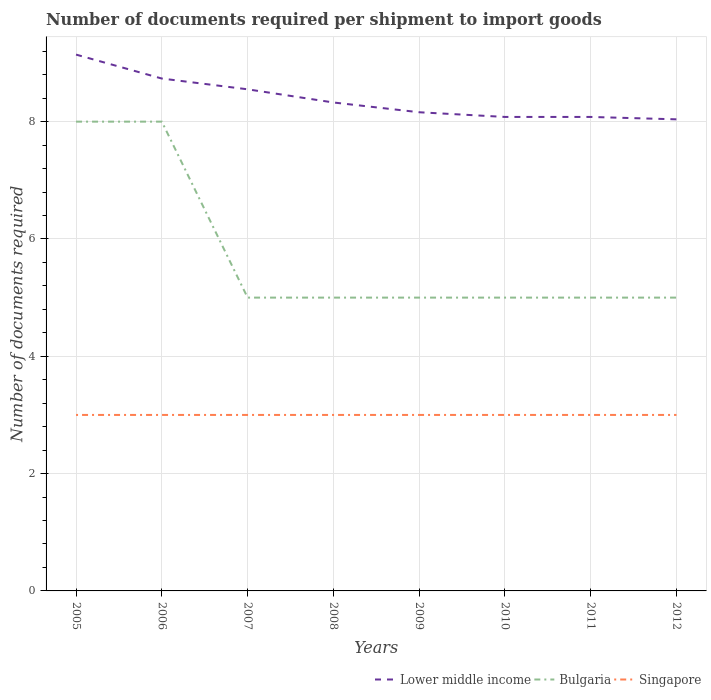Does the line corresponding to Bulgaria intersect with the line corresponding to Singapore?
Your answer should be compact. No. Is the number of lines equal to the number of legend labels?
Offer a terse response. Yes. Across all years, what is the maximum number of documents required per shipment to import goods in Singapore?
Keep it short and to the point. 3. What is the total number of documents required per shipment to import goods in Lower middle income in the graph?
Provide a succinct answer. 0.41. What is the difference between the highest and the lowest number of documents required per shipment to import goods in Lower middle income?
Provide a succinct answer. 3. How many lines are there?
Keep it short and to the point. 3. Where does the legend appear in the graph?
Provide a short and direct response. Bottom right. How many legend labels are there?
Give a very brief answer. 3. What is the title of the graph?
Provide a succinct answer. Number of documents required per shipment to import goods. What is the label or title of the Y-axis?
Make the answer very short. Number of documents required. What is the Number of documents required in Lower middle income in 2005?
Your response must be concise. 9.14. What is the Number of documents required in Lower middle income in 2006?
Your answer should be compact. 8.73. What is the Number of documents required of Bulgaria in 2006?
Provide a succinct answer. 8. What is the Number of documents required of Lower middle income in 2007?
Give a very brief answer. 8.55. What is the Number of documents required of Lower middle income in 2008?
Ensure brevity in your answer.  8.33. What is the Number of documents required in Bulgaria in 2008?
Your answer should be very brief. 5. What is the Number of documents required in Singapore in 2008?
Your answer should be compact. 3. What is the Number of documents required of Lower middle income in 2009?
Make the answer very short. 8.16. What is the Number of documents required of Lower middle income in 2010?
Ensure brevity in your answer.  8.08. What is the Number of documents required of Lower middle income in 2011?
Your answer should be compact. 8.08. What is the Number of documents required in Bulgaria in 2011?
Offer a terse response. 5. What is the Number of documents required in Singapore in 2011?
Give a very brief answer. 3. What is the Number of documents required in Lower middle income in 2012?
Your response must be concise. 8.04. What is the Number of documents required in Bulgaria in 2012?
Ensure brevity in your answer.  5. What is the Number of documents required in Singapore in 2012?
Keep it short and to the point. 3. Across all years, what is the maximum Number of documents required in Lower middle income?
Ensure brevity in your answer.  9.14. Across all years, what is the maximum Number of documents required of Bulgaria?
Provide a short and direct response. 8. Across all years, what is the minimum Number of documents required of Lower middle income?
Offer a terse response. 8.04. Across all years, what is the minimum Number of documents required of Bulgaria?
Provide a succinct answer. 5. What is the total Number of documents required of Lower middle income in the graph?
Offer a very short reply. 67.11. What is the total Number of documents required in Bulgaria in the graph?
Your answer should be very brief. 46. What is the total Number of documents required in Singapore in the graph?
Provide a succinct answer. 24. What is the difference between the Number of documents required in Lower middle income in 2005 and that in 2006?
Provide a short and direct response. 0.41. What is the difference between the Number of documents required of Lower middle income in 2005 and that in 2007?
Offer a very short reply. 0.59. What is the difference between the Number of documents required of Bulgaria in 2005 and that in 2007?
Offer a very short reply. 3. What is the difference between the Number of documents required in Singapore in 2005 and that in 2007?
Ensure brevity in your answer.  0. What is the difference between the Number of documents required in Lower middle income in 2005 and that in 2008?
Your answer should be compact. 0.82. What is the difference between the Number of documents required of Bulgaria in 2005 and that in 2008?
Your answer should be very brief. 3. What is the difference between the Number of documents required of Singapore in 2005 and that in 2008?
Offer a very short reply. 0. What is the difference between the Number of documents required of Lower middle income in 2005 and that in 2009?
Make the answer very short. 0.98. What is the difference between the Number of documents required in Lower middle income in 2005 and that in 2010?
Offer a terse response. 1.06. What is the difference between the Number of documents required of Bulgaria in 2005 and that in 2010?
Give a very brief answer. 3. What is the difference between the Number of documents required of Lower middle income in 2005 and that in 2011?
Your response must be concise. 1.06. What is the difference between the Number of documents required in Bulgaria in 2005 and that in 2011?
Provide a short and direct response. 3. What is the difference between the Number of documents required of Lower middle income in 2005 and that in 2012?
Your answer should be compact. 1.1. What is the difference between the Number of documents required in Bulgaria in 2005 and that in 2012?
Provide a succinct answer. 3. What is the difference between the Number of documents required of Lower middle income in 2006 and that in 2007?
Keep it short and to the point. 0.18. What is the difference between the Number of documents required in Singapore in 2006 and that in 2007?
Keep it short and to the point. 0. What is the difference between the Number of documents required in Lower middle income in 2006 and that in 2008?
Make the answer very short. 0.41. What is the difference between the Number of documents required of Lower middle income in 2006 and that in 2009?
Provide a short and direct response. 0.57. What is the difference between the Number of documents required of Bulgaria in 2006 and that in 2009?
Offer a very short reply. 3. What is the difference between the Number of documents required in Lower middle income in 2006 and that in 2010?
Ensure brevity in your answer.  0.65. What is the difference between the Number of documents required in Singapore in 2006 and that in 2010?
Provide a succinct answer. 0. What is the difference between the Number of documents required of Lower middle income in 2006 and that in 2011?
Provide a succinct answer. 0.65. What is the difference between the Number of documents required in Bulgaria in 2006 and that in 2011?
Keep it short and to the point. 3. What is the difference between the Number of documents required of Singapore in 2006 and that in 2011?
Ensure brevity in your answer.  0. What is the difference between the Number of documents required of Lower middle income in 2006 and that in 2012?
Give a very brief answer. 0.7. What is the difference between the Number of documents required in Singapore in 2006 and that in 2012?
Offer a very short reply. 0. What is the difference between the Number of documents required of Lower middle income in 2007 and that in 2008?
Give a very brief answer. 0.22. What is the difference between the Number of documents required of Bulgaria in 2007 and that in 2008?
Give a very brief answer. 0. What is the difference between the Number of documents required of Lower middle income in 2007 and that in 2009?
Make the answer very short. 0.39. What is the difference between the Number of documents required in Singapore in 2007 and that in 2009?
Give a very brief answer. 0. What is the difference between the Number of documents required in Lower middle income in 2007 and that in 2010?
Your response must be concise. 0.47. What is the difference between the Number of documents required in Lower middle income in 2007 and that in 2011?
Keep it short and to the point. 0.47. What is the difference between the Number of documents required in Bulgaria in 2007 and that in 2011?
Provide a short and direct response. 0. What is the difference between the Number of documents required in Singapore in 2007 and that in 2011?
Provide a short and direct response. 0. What is the difference between the Number of documents required of Lower middle income in 2007 and that in 2012?
Your answer should be very brief. 0.51. What is the difference between the Number of documents required of Bulgaria in 2007 and that in 2012?
Offer a terse response. 0. What is the difference between the Number of documents required in Singapore in 2007 and that in 2012?
Provide a short and direct response. 0. What is the difference between the Number of documents required of Lower middle income in 2008 and that in 2009?
Offer a terse response. 0.17. What is the difference between the Number of documents required in Bulgaria in 2008 and that in 2009?
Make the answer very short. 0. What is the difference between the Number of documents required of Singapore in 2008 and that in 2009?
Your answer should be very brief. 0. What is the difference between the Number of documents required in Lower middle income in 2008 and that in 2010?
Your answer should be compact. 0.25. What is the difference between the Number of documents required of Bulgaria in 2008 and that in 2010?
Give a very brief answer. 0. What is the difference between the Number of documents required in Singapore in 2008 and that in 2010?
Keep it short and to the point. 0. What is the difference between the Number of documents required in Lower middle income in 2008 and that in 2011?
Give a very brief answer. 0.25. What is the difference between the Number of documents required in Lower middle income in 2008 and that in 2012?
Provide a succinct answer. 0.29. What is the difference between the Number of documents required in Bulgaria in 2008 and that in 2012?
Give a very brief answer. 0. What is the difference between the Number of documents required of Lower middle income in 2009 and that in 2011?
Your answer should be compact. 0.08. What is the difference between the Number of documents required in Bulgaria in 2009 and that in 2011?
Offer a very short reply. 0. What is the difference between the Number of documents required in Lower middle income in 2009 and that in 2012?
Provide a short and direct response. 0.12. What is the difference between the Number of documents required in Bulgaria in 2009 and that in 2012?
Your answer should be compact. 0. What is the difference between the Number of documents required in Singapore in 2009 and that in 2012?
Keep it short and to the point. 0. What is the difference between the Number of documents required of Lower middle income in 2010 and that in 2012?
Offer a very short reply. 0.04. What is the difference between the Number of documents required in Singapore in 2010 and that in 2012?
Provide a succinct answer. 0. What is the difference between the Number of documents required of Lower middle income in 2011 and that in 2012?
Keep it short and to the point. 0.04. What is the difference between the Number of documents required in Bulgaria in 2011 and that in 2012?
Keep it short and to the point. 0. What is the difference between the Number of documents required in Singapore in 2011 and that in 2012?
Keep it short and to the point. 0. What is the difference between the Number of documents required in Lower middle income in 2005 and the Number of documents required in Bulgaria in 2006?
Provide a succinct answer. 1.14. What is the difference between the Number of documents required of Lower middle income in 2005 and the Number of documents required of Singapore in 2006?
Your answer should be very brief. 6.14. What is the difference between the Number of documents required of Lower middle income in 2005 and the Number of documents required of Bulgaria in 2007?
Provide a short and direct response. 4.14. What is the difference between the Number of documents required in Lower middle income in 2005 and the Number of documents required in Singapore in 2007?
Give a very brief answer. 6.14. What is the difference between the Number of documents required in Bulgaria in 2005 and the Number of documents required in Singapore in 2007?
Your response must be concise. 5. What is the difference between the Number of documents required of Lower middle income in 2005 and the Number of documents required of Bulgaria in 2008?
Ensure brevity in your answer.  4.14. What is the difference between the Number of documents required in Lower middle income in 2005 and the Number of documents required in Singapore in 2008?
Your answer should be compact. 6.14. What is the difference between the Number of documents required in Bulgaria in 2005 and the Number of documents required in Singapore in 2008?
Your response must be concise. 5. What is the difference between the Number of documents required in Lower middle income in 2005 and the Number of documents required in Bulgaria in 2009?
Give a very brief answer. 4.14. What is the difference between the Number of documents required of Lower middle income in 2005 and the Number of documents required of Singapore in 2009?
Provide a short and direct response. 6.14. What is the difference between the Number of documents required in Bulgaria in 2005 and the Number of documents required in Singapore in 2009?
Your answer should be very brief. 5. What is the difference between the Number of documents required of Lower middle income in 2005 and the Number of documents required of Bulgaria in 2010?
Your answer should be compact. 4.14. What is the difference between the Number of documents required in Lower middle income in 2005 and the Number of documents required in Singapore in 2010?
Make the answer very short. 6.14. What is the difference between the Number of documents required in Lower middle income in 2005 and the Number of documents required in Bulgaria in 2011?
Make the answer very short. 4.14. What is the difference between the Number of documents required in Lower middle income in 2005 and the Number of documents required in Singapore in 2011?
Your answer should be compact. 6.14. What is the difference between the Number of documents required of Bulgaria in 2005 and the Number of documents required of Singapore in 2011?
Your answer should be very brief. 5. What is the difference between the Number of documents required of Lower middle income in 2005 and the Number of documents required of Bulgaria in 2012?
Keep it short and to the point. 4.14. What is the difference between the Number of documents required of Lower middle income in 2005 and the Number of documents required of Singapore in 2012?
Keep it short and to the point. 6.14. What is the difference between the Number of documents required of Bulgaria in 2005 and the Number of documents required of Singapore in 2012?
Give a very brief answer. 5. What is the difference between the Number of documents required of Lower middle income in 2006 and the Number of documents required of Bulgaria in 2007?
Offer a very short reply. 3.73. What is the difference between the Number of documents required in Lower middle income in 2006 and the Number of documents required in Singapore in 2007?
Give a very brief answer. 5.73. What is the difference between the Number of documents required of Lower middle income in 2006 and the Number of documents required of Bulgaria in 2008?
Make the answer very short. 3.73. What is the difference between the Number of documents required in Lower middle income in 2006 and the Number of documents required in Singapore in 2008?
Your answer should be compact. 5.73. What is the difference between the Number of documents required in Lower middle income in 2006 and the Number of documents required in Bulgaria in 2009?
Make the answer very short. 3.73. What is the difference between the Number of documents required in Lower middle income in 2006 and the Number of documents required in Singapore in 2009?
Give a very brief answer. 5.73. What is the difference between the Number of documents required in Bulgaria in 2006 and the Number of documents required in Singapore in 2009?
Give a very brief answer. 5. What is the difference between the Number of documents required in Lower middle income in 2006 and the Number of documents required in Bulgaria in 2010?
Your response must be concise. 3.73. What is the difference between the Number of documents required in Lower middle income in 2006 and the Number of documents required in Singapore in 2010?
Make the answer very short. 5.73. What is the difference between the Number of documents required in Lower middle income in 2006 and the Number of documents required in Bulgaria in 2011?
Give a very brief answer. 3.73. What is the difference between the Number of documents required in Lower middle income in 2006 and the Number of documents required in Singapore in 2011?
Offer a terse response. 5.73. What is the difference between the Number of documents required in Lower middle income in 2006 and the Number of documents required in Bulgaria in 2012?
Offer a terse response. 3.73. What is the difference between the Number of documents required of Lower middle income in 2006 and the Number of documents required of Singapore in 2012?
Give a very brief answer. 5.73. What is the difference between the Number of documents required of Lower middle income in 2007 and the Number of documents required of Bulgaria in 2008?
Give a very brief answer. 3.55. What is the difference between the Number of documents required in Lower middle income in 2007 and the Number of documents required in Singapore in 2008?
Your answer should be very brief. 5.55. What is the difference between the Number of documents required in Bulgaria in 2007 and the Number of documents required in Singapore in 2008?
Your answer should be compact. 2. What is the difference between the Number of documents required of Lower middle income in 2007 and the Number of documents required of Bulgaria in 2009?
Your answer should be compact. 3.55. What is the difference between the Number of documents required of Lower middle income in 2007 and the Number of documents required of Singapore in 2009?
Offer a terse response. 5.55. What is the difference between the Number of documents required of Lower middle income in 2007 and the Number of documents required of Bulgaria in 2010?
Your response must be concise. 3.55. What is the difference between the Number of documents required of Lower middle income in 2007 and the Number of documents required of Singapore in 2010?
Ensure brevity in your answer.  5.55. What is the difference between the Number of documents required in Bulgaria in 2007 and the Number of documents required in Singapore in 2010?
Make the answer very short. 2. What is the difference between the Number of documents required in Lower middle income in 2007 and the Number of documents required in Bulgaria in 2011?
Provide a short and direct response. 3.55. What is the difference between the Number of documents required in Lower middle income in 2007 and the Number of documents required in Singapore in 2011?
Offer a very short reply. 5.55. What is the difference between the Number of documents required of Bulgaria in 2007 and the Number of documents required of Singapore in 2011?
Your answer should be very brief. 2. What is the difference between the Number of documents required in Lower middle income in 2007 and the Number of documents required in Bulgaria in 2012?
Your answer should be compact. 3.55. What is the difference between the Number of documents required in Lower middle income in 2007 and the Number of documents required in Singapore in 2012?
Give a very brief answer. 5.55. What is the difference between the Number of documents required in Lower middle income in 2008 and the Number of documents required in Bulgaria in 2009?
Keep it short and to the point. 3.33. What is the difference between the Number of documents required of Lower middle income in 2008 and the Number of documents required of Singapore in 2009?
Make the answer very short. 5.33. What is the difference between the Number of documents required of Lower middle income in 2008 and the Number of documents required of Bulgaria in 2010?
Your answer should be very brief. 3.33. What is the difference between the Number of documents required of Lower middle income in 2008 and the Number of documents required of Singapore in 2010?
Your answer should be compact. 5.33. What is the difference between the Number of documents required of Bulgaria in 2008 and the Number of documents required of Singapore in 2010?
Offer a terse response. 2. What is the difference between the Number of documents required of Lower middle income in 2008 and the Number of documents required of Bulgaria in 2011?
Keep it short and to the point. 3.33. What is the difference between the Number of documents required in Lower middle income in 2008 and the Number of documents required in Singapore in 2011?
Your answer should be very brief. 5.33. What is the difference between the Number of documents required in Bulgaria in 2008 and the Number of documents required in Singapore in 2011?
Your answer should be compact. 2. What is the difference between the Number of documents required in Lower middle income in 2008 and the Number of documents required in Bulgaria in 2012?
Offer a terse response. 3.33. What is the difference between the Number of documents required in Lower middle income in 2008 and the Number of documents required in Singapore in 2012?
Your response must be concise. 5.33. What is the difference between the Number of documents required of Lower middle income in 2009 and the Number of documents required of Bulgaria in 2010?
Your answer should be compact. 3.16. What is the difference between the Number of documents required in Lower middle income in 2009 and the Number of documents required in Singapore in 2010?
Your answer should be very brief. 5.16. What is the difference between the Number of documents required of Lower middle income in 2009 and the Number of documents required of Bulgaria in 2011?
Your answer should be very brief. 3.16. What is the difference between the Number of documents required in Lower middle income in 2009 and the Number of documents required in Singapore in 2011?
Offer a very short reply. 5.16. What is the difference between the Number of documents required in Bulgaria in 2009 and the Number of documents required in Singapore in 2011?
Give a very brief answer. 2. What is the difference between the Number of documents required of Lower middle income in 2009 and the Number of documents required of Bulgaria in 2012?
Make the answer very short. 3.16. What is the difference between the Number of documents required of Lower middle income in 2009 and the Number of documents required of Singapore in 2012?
Give a very brief answer. 5.16. What is the difference between the Number of documents required of Lower middle income in 2010 and the Number of documents required of Bulgaria in 2011?
Provide a succinct answer. 3.08. What is the difference between the Number of documents required of Lower middle income in 2010 and the Number of documents required of Singapore in 2011?
Ensure brevity in your answer.  5.08. What is the difference between the Number of documents required of Lower middle income in 2010 and the Number of documents required of Bulgaria in 2012?
Ensure brevity in your answer.  3.08. What is the difference between the Number of documents required in Lower middle income in 2010 and the Number of documents required in Singapore in 2012?
Provide a succinct answer. 5.08. What is the difference between the Number of documents required in Lower middle income in 2011 and the Number of documents required in Bulgaria in 2012?
Your answer should be very brief. 3.08. What is the difference between the Number of documents required in Lower middle income in 2011 and the Number of documents required in Singapore in 2012?
Your answer should be very brief. 5.08. What is the difference between the Number of documents required in Bulgaria in 2011 and the Number of documents required in Singapore in 2012?
Provide a short and direct response. 2. What is the average Number of documents required of Lower middle income per year?
Your response must be concise. 8.39. What is the average Number of documents required in Bulgaria per year?
Offer a terse response. 5.75. In the year 2005, what is the difference between the Number of documents required in Lower middle income and Number of documents required in Bulgaria?
Offer a terse response. 1.14. In the year 2005, what is the difference between the Number of documents required of Lower middle income and Number of documents required of Singapore?
Your answer should be very brief. 6.14. In the year 2005, what is the difference between the Number of documents required in Bulgaria and Number of documents required in Singapore?
Ensure brevity in your answer.  5. In the year 2006, what is the difference between the Number of documents required of Lower middle income and Number of documents required of Bulgaria?
Give a very brief answer. 0.73. In the year 2006, what is the difference between the Number of documents required in Lower middle income and Number of documents required in Singapore?
Provide a short and direct response. 5.73. In the year 2007, what is the difference between the Number of documents required in Lower middle income and Number of documents required in Bulgaria?
Keep it short and to the point. 3.55. In the year 2007, what is the difference between the Number of documents required in Lower middle income and Number of documents required in Singapore?
Provide a succinct answer. 5.55. In the year 2008, what is the difference between the Number of documents required in Lower middle income and Number of documents required in Bulgaria?
Offer a terse response. 3.33. In the year 2008, what is the difference between the Number of documents required of Lower middle income and Number of documents required of Singapore?
Offer a terse response. 5.33. In the year 2009, what is the difference between the Number of documents required of Lower middle income and Number of documents required of Bulgaria?
Offer a very short reply. 3.16. In the year 2009, what is the difference between the Number of documents required of Lower middle income and Number of documents required of Singapore?
Make the answer very short. 5.16. In the year 2009, what is the difference between the Number of documents required in Bulgaria and Number of documents required in Singapore?
Your response must be concise. 2. In the year 2010, what is the difference between the Number of documents required in Lower middle income and Number of documents required in Bulgaria?
Provide a succinct answer. 3.08. In the year 2010, what is the difference between the Number of documents required in Lower middle income and Number of documents required in Singapore?
Offer a very short reply. 5.08. In the year 2011, what is the difference between the Number of documents required in Lower middle income and Number of documents required in Bulgaria?
Ensure brevity in your answer.  3.08. In the year 2011, what is the difference between the Number of documents required in Lower middle income and Number of documents required in Singapore?
Provide a succinct answer. 5.08. In the year 2011, what is the difference between the Number of documents required of Bulgaria and Number of documents required of Singapore?
Provide a short and direct response. 2. In the year 2012, what is the difference between the Number of documents required in Lower middle income and Number of documents required in Bulgaria?
Offer a terse response. 3.04. In the year 2012, what is the difference between the Number of documents required of Lower middle income and Number of documents required of Singapore?
Make the answer very short. 5.04. What is the ratio of the Number of documents required in Lower middle income in 2005 to that in 2006?
Your response must be concise. 1.05. What is the ratio of the Number of documents required in Bulgaria in 2005 to that in 2006?
Give a very brief answer. 1. What is the ratio of the Number of documents required in Singapore in 2005 to that in 2006?
Your answer should be very brief. 1. What is the ratio of the Number of documents required in Lower middle income in 2005 to that in 2007?
Keep it short and to the point. 1.07. What is the ratio of the Number of documents required in Singapore in 2005 to that in 2007?
Give a very brief answer. 1. What is the ratio of the Number of documents required in Lower middle income in 2005 to that in 2008?
Make the answer very short. 1.1. What is the ratio of the Number of documents required of Lower middle income in 2005 to that in 2009?
Your answer should be compact. 1.12. What is the ratio of the Number of documents required in Lower middle income in 2005 to that in 2010?
Make the answer very short. 1.13. What is the ratio of the Number of documents required of Bulgaria in 2005 to that in 2010?
Your response must be concise. 1.6. What is the ratio of the Number of documents required of Lower middle income in 2005 to that in 2011?
Provide a short and direct response. 1.13. What is the ratio of the Number of documents required of Bulgaria in 2005 to that in 2011?
Provide a short and direct response. 1.6. What is the ratio of the Number of documents required in Singapore in 2005 to that in 2011?
Give a very brief answer. 1. What is the ratio of the Number of documents required in Lower middle income in 2005 to that in 2012?
Your answer should be compact. 1.14. What is the ratio of the Number of documents required of Bulgaria in 2005 to that in 2012?
Keep it short and to the point. 1.6. What is the ratio of the Number of documents required in Singapore in 2005 to that in 2012?
Make the answer very short. 1. What is the ratio of the Number of documents required in Lower middle income in 2006 to that in 2007?
Offer a very short reply. 1.02. What is the ratio of the Number of documents required of Singapore in 2006 to that in 2007?
Your answer should be very brief. 1. What is the ratio of the Number of documents required in Lower middle income in 2006 to that in 2008?
Provide a succinct answer. 1.05. What is the ratio of the Number of documents required of Singapore in 2006 to that in 2008?
Provide a succinct answer. 1. What is the ratio of the Number of documents required of Lower middle income in 2006 to that in 2009?
Give a very brief answer. 1.07. What is the ratio of the Number of documents required in Singapore in 2006 to that in 2009?
Your response must be concise. 1. What is the ratio of the Number of documents required in Lower middle income in 2006 to that in 2010?
Keep it short and to the point. 1.08. What is the ratio of the Number of documents required in Bulgaria in 2006 to that in 2010?
Offer a terse response. 1.6. What is the ratio of the Number of documents required of Singapore in 2006 to that in 2010?
Give a very brief answer. 1. What is the ratio of the Number of documents required of Lower middle income in 2006 to that in 2011?
Provide a succinct answer. 1.08. What is the ratio of the Number of documents required in Bulgaria in 2006 to that in 2011?
Ensure brevity in your answer.  1.6. What is the ratio of the Number of documents required in Singapore in 2006 to that in 2011?
Offer a very short reply. 1. What is the ratio of the Number of documents required in Lower middle income in 2006 to that in 2012?
Provide a succinct answer. 1.09. What is the ratio of the Number of documents required of Singapore in 2006 to that in 2012?
Provide a short and direct response. 1. What is the ratio of the Number of documents required of Lower middle income in 2007 to that in 2008?
Provide a short and direct response. 1.03. What is the ratio of the Number of documents required in Singapore in 2007 to that in 2008?
Make the answer very short. 1. What is the ratio of the Number of documents required of Lower middle income in 2007 to that in 2009?
Keep it short and to the point. 1.05. What is the ratio of the Number of documents required in Lower middle income in 2007 to that in 2010?
Give a very brief answer. 1.06. What is the ratio of the Number of documents required of Singapore in 2007 to that in 2010?
Offer a very short reply. 1. What is the ratio of the Number of documents required of Lower middle income in 2007 to that in 2011?
Keep it short and to the point. 1.06. What is the ratio of the Number of documents required of Bulgaria in 2007 to that in 2011?
Provide a short and direct response. 1. What is the ratio of the Number of documents required in Lower middle income in 2007 to that in 2012?
Offer a terse response. 1.06. What is the ratio of the Number of documents required of Singapore in 2007 to that in 2012?
Offer a terse response. 1. What is the ratio of the Number of documents required in Lower middle income in 2008 to that in 2009?
Provide a short and direct response. 1.02. What is the ratio of the Number of documents required of Bulgaria in 2008 to that in 2009?
Give a very brief answer. 1. What is the ratio of the Number of documents required of Singapore in 2008 to that in 2009?
Your answer should be compact. 1. What is the ratio of the Number of documents required in Lower middle income in 2008 to that in 2010?
Give a very brief answer. 1.03. What is the ratio of the Number of documents required of Lower middle income in 2008 to that in 2011?
Provide a succinct answer. 1.03. What is the ratio of the Number of documents required in Singapore in 2008 to that in 2011?
Your answer should be compact. 1. What is the ratio of the Number of documents required of Lower middle income in 2008 to that in 2012?
Your answer should be very brief. 1.04. What is the ratio of the Number of documents required of Singapore in 2008 to that in 2012?
Give a very brief answer. 1. What is the ratio of the Number of documents required of Lower middle income in 2009 to that in 2010?
Your answer should be very brief. 1.01. What is the ratio of the Number of documents required of Bulgaria in 2009 to that in 2010?
Provide a short and direct response. 1. What is the ratio of the Number of documents required in Singapore in 2009 to that in 2010?
Your response must be concise. 1. What is the ratio of the Number of documents required of Lower middle income in 2009 to that in 2011?
Ensure brevity in your answer.  1.01. What is the ratio of the Number of documents required in Singapore in 2009 to that in 2011?
Your answer should be very brief. 1. What is the ratio of the Number of documents required in Singapore in 2010 to that in 2012?
Ensure brevity in your answer.  1. What is the ratio of the Number of documents required in Lower middle income in 2011 to that in 2012?
Ensure brevity in your answer.  1.01. What is the ratio of the Number of documents required of Singapore in 2011 to that in 2012?
Make the answer very short. 1. What is the difference between the highest and the second highest Number of documents required in Lower middle income?
Provide a succinct answer. 0.41. What is the difference between the highest and the second highest Number of documents required of Bulgaria?
Your response must be concise. 0. What is the difference between the highest and the second highest Number of documents required of Singapore?
Your answer should be very brief. 0. What is the difference between the highest and the lowest Number of documents required of Lower middle income?
Your answer should be compact. 1.1. 